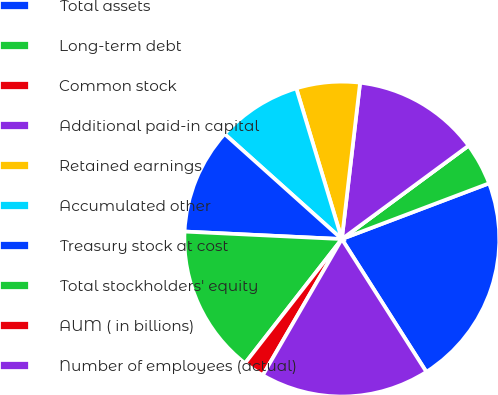Convert chart. <chart><loc_0><loc_0><loc_500><loc_500><pie_chart><fcel>Total assets<fcel>Long-term debt<fcel>Common stock<fcel>Additional paid-in capital<fcel>Retained earnings<fcel>Accumulated other<fcel>Treasury stock at cost<fcel>Total stockholders' equity<fcel>AUM ( in billions)<fcel>Number of employees (actual)<nl><fcel>21.74%<fcel>4.35%<fcel>0.0%<fcel>13.04%<fcel>6.52%<fcel>8.7%<fcel>10.87%<fcel>15.22%<fcel>2.17%<fcel>17.39%<nl></chart> 